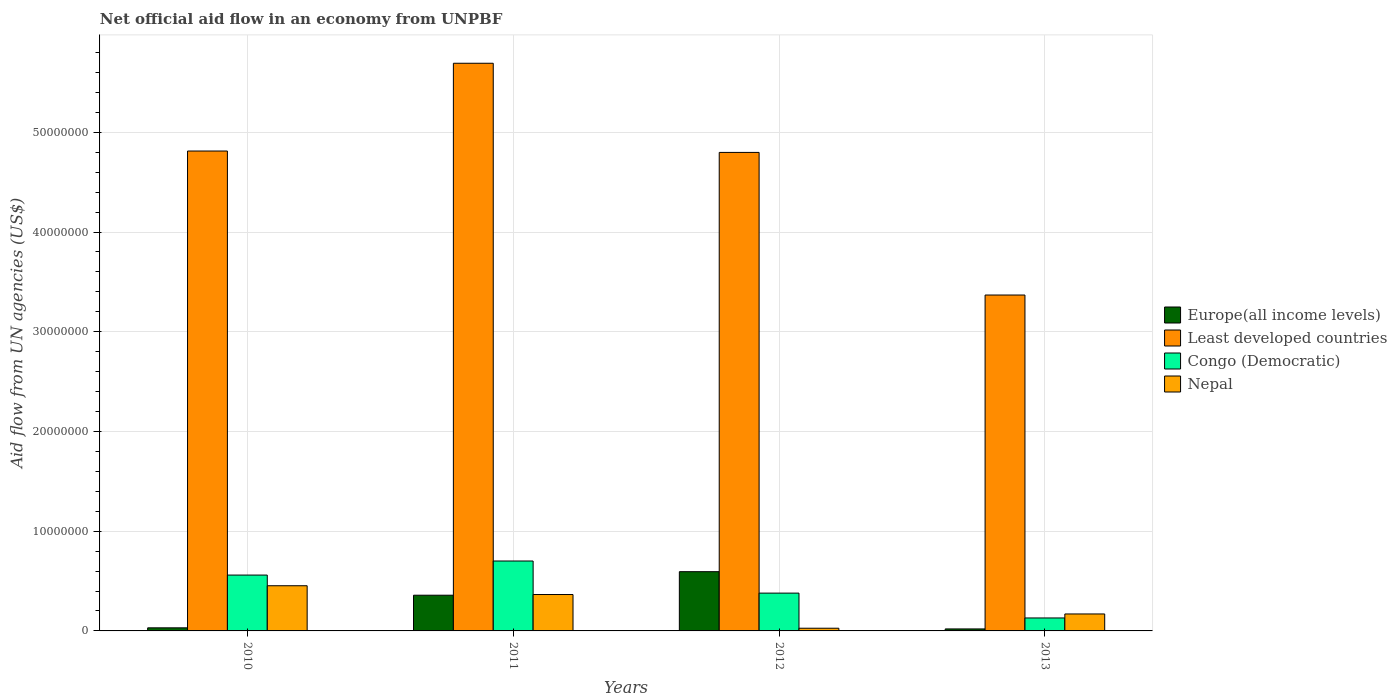Are the number of bars per tick equal to the number of legend labels?
Your answer should be very brief. Yes. Are the number of bars on each tick of the X-axis equal?
Offer a very short reply. Yes. How many bars are there on the 2nd tick from the right?
Provide a short and direct response. 4. What is the label of the 4th group of bars from the left?
Offer a terse response. 2013. In how many cases, is the number of bars for a given year not equal to the number of legend labels?
Your answer should be compact. 0. What is the net official aid flow in Europe(all income levels) in 2010?
Keep it short and to the point. 3.10e+05. Across all years, what is the maximum net official aid flow in Nepal?
Keep it short and to the point. 4.53e+06. Across all years, what is the minimum net official aid flow in Congo (Democratic)?
Provide a succinct answer. 1.30e+06. What is the total net official aid flow in Europe(all income levels) in the graph?
Keep it short and to the point. 1.00e+07. What is the difference between the net official aid flow in Europe(all income levels) in 2012 and that in 2013?
Ensure brevity in your answer.  5.74e+06. What is the difference between the net official aid flow in Europe(all income levels) in 2010 and the net official aid flow in Congo (Democratic) in 2012?
Your answer should be very brief. -3.48e+06. What is the average net official aid flow in Nepal per year?
Give a very brief answer. 2.54e+06. In the year 2013, what is the difference between the net official aid flow in Least developed countries and net official aid flow in Europe(all income levels)?
Give a very brief answer. 3.35e+07. In how many years, is the net official aid flow in Europe(all income levels) greater than 12000000 US$?
Provide a succinct answer. 0. What is the ratio of the net official aid flow in Nepal in 2010 to that in 2011?
Make the answer very short. 1.24. Is the difference between the net official aid flow in Least developed countries in 2011 and 2012 greater than the difference between the net official aid flow in Europe(all income levels) in 2011 and 2012?
Your answer should be very brief. Yes. What is the difference between the highest and the second highest net official aid flow in Europe(all income levels)?
Ensure brevity in your answer.  2.36e+06. What is the difference between the highest and the lowest net official aid flow in Least developed countries?
Provide a succinct answer. 2.32e+07. What does the 1st bar from the left in 2011 represents?
Offer a very short reply. Europe(all income levels). What does the 1st bar from the right in 2012 represents?
Provide a short and direct response. Nepal. Is it the case that in every year, the sum of the net official aid flow in Nepal and net official aid flow in Least developed countries is greater than the net official aid flow in Congo (Democratic)?
Offer a very short reply. Yes. Are the values on the major ticks of Y-axis written in scientific E-notation?
Keep it short and to the point. No. Does the graph contain any zero values?
Your answer should be compact. No. Does the graph contain grids?
Make the answer very short. Yes. What is the title of the graph?
Give a very brief answer. Net official aid flow in an economy from UNPBF. What is the label or title of the X-axis?
Offer a very short reply. Years. What is the label or title of the Y-axis?
Offer a terse response. Aid flow from UN agencies (US$). What is the Aid flow from UN agencies (US$) in Europe(all income levels) in 2010?
Keep it short and to the point. 3.10e+05. What is the Aid flow from UN agencies (US$) in Least developed countries in 2010?
Your answer should be compact. 4.81e+07. What is the Aid flow from UN agencies (US$) in Congo (Democratic) in 2010?
Provide a short and direct response. 5.60e+06. What is the Aid flow from UN agencies (US$) in Nepal in 2010?
Offer a very short reply. 4.53e+06. What is the Aid flow from UN agencies (US$) in Europe(all income levels) in 2011?
Give a very brief answer. 3.58e+06. What is the Aid flow from UN agencies (US$) of Least developed countries in 2011?
Your response must be concise. 5.69e+07. What is the Aid flow from UN agencies (US$) of Congo (Democratic) in 2011?
Give a very brief answer. 7.01e+06. What is the Aid flow from UN agencies (US$) of Nepal in 2011?
Provide a succinct answer. 3.65e+06. What is the Aid flow from UN agencies (US$) of Europe(all income levels) in 2012?
Ensure brevity in your answer.  5.94e+06. What is the Aid flow from UN agencies (US$) of Least developed countries in 2012?
Keep it short and to the point. 4.80e+07. What is the Aid flow from UN agencies (US$) of Congo (Democratic) in 2012?
Ensure brevity in your answer.  3.79e+06. What is the Aid flow from UN agencies (US$) in Nepal in 2012?
Your answer should be very brief. 2.70e+05. What is the Aid flow from UN agencies (US$) in Europe(all income levels) in 2013?
Give a very brief answer. 2.00e+05. What is the Aid flow from UN agencies (US$) in Least developed countries in 2013?
Provide a succinct answer. 3.37e+07. What is the Aid flow from UN agencies (US$) of Congo (Democratic) in 2013?
Your answer should be very brief. 1.30e+06. What is the Aid flow from UN agencies (US$) in Nepal in 2013?
Offer a terse response. 1.70e+06. Across all years, what is the maximum Aid flow from UN agencies (US$) in Europe(all income levels)?
Offer a very short reply. 5.94e+06. Across all years, what is the maximum Aid flow from UN agencies (US$) of Least developed countries?
Offer a terse response. 5.69e+07. Across all years, what is the maximum Aid flow from UN agencies (US$) in Congo (Democratic)?
Give a very brief answer. 7.01e+06. Across all years, what is the maximum Aid flow from UN agencies (US$) of Nepal?
Your answer should be very brief. 4.53e+06. Across all years, what is the minimum Aid flow from UN agencies (US$) of Europe(all income levels)?
Offer a terse response. 2.00e+05. Across all years, what is the minimum Aid flow from UN agencies (US$) in Least developed countries?
Provide a succinct answer. 3.37e+07. Across all years, what is the minimum Aid flow from UN agencies (US$) in Congo (Democratic)?
Make the answer very short. 1.30e+06. Across all years, what is the minimum Aid flow from UN agencies (US$) in Nepal?
Your response must be concise. 2.70e+05. What is the total Aid flow from UN agencies (US$) in Europe(all income levels) in the graph?
Make the answer very short. 1.00e+07. What is the total Aid flow from UN agencies (US$) of Least developed countries in the graph?
Offer a terse response. 1.87e+08. What is the total Aid flow from UN agencies (US$) of Congo (Democratic) in the graph?
Your response must be concise. 1.77e+07. What is the total Aid flow from UN agencies (US$) of Nepal in the graph?
Make the answer very short. 1.02e+07. What is the difference between the Aid flow from UN agencies (US$) in Europe(all income levels) in 2010 and that in 2011?
Your response must be concise. -3.27e+06. What is the difference between the Aid flow from UN agencies (US$) of Least developed countries in 2010 and that in 2011?
Provide a succinct answer. -8.80e+06. What is the difference between the Aid flow from UN agencies (US$) in Congo (Democratic) in 2010 and that in 2011?
Keep it short and to the point. -1.41e+06. What is the difference between the Aid flow from UN agencies (US$) of Nepal in 2010 and that in 2011?
Your response must be concise. 8.80e+05. What is the difference between the Aid flow from UN agencies (US$) in Europe(all income levels) in 2010 and that in 2012?
Keep it short and to the point. -5.63e+06. What is the difference between the Aid flow from UN agencies (US$) in Congo (Democratic) in 2010 and that in 2012?
Offer a very short reply. 1.81e+06. What is the difference between the Aid flow from UN agencies (US$) in Nepal in 2010 and that in 2012?
Your answer should be compact. 4.26e+06. What is the difference between the Aid flow from UN agencies (US$) in Least developed countries in 2010 and that in 2013?
Give a very brief answer. 1.44e+07. What is the difference between the Aid flow from UN agencies (US$) in Congo (Democratic) in 2010 and that in 2013?
Provide a succinct answer. 4.30e+06. What is the difference between the Aid flow from UN agencies (US$) of Nepal in 2010 and that in 2013?
Provide a succinct answer. 2.83e+06. What is the difference between the Aid flow from UN agencies (US$) of Europe(all income levels) in 2011 and that in 2012?
Offer a very short reply. -2.36e+06. What is the difference between the Aid flow from UN agencies (US$) of Least developed countries in 2011 and that in 2012?
Your answer should be very brief. 8.94e+06. What is the difference between the Aid flow from UN agencies (US$) in Congo (Democratic) in 2011 and that in 2012?
Offer a terse response. 3.22e+06. What is the difference between the Aid flow from UN agencies (US$) in Nepal in 2011 and that in 2012?
Give a very brief answer. 3.38e+06. What is the difference between the Aid flow from UN agencies (US$) of Europe(all income levels) in 2011 and that in 2013?
Provide a short and direct response. 3.38e+06. What is the difference between the Aid flow from UN agencies (US$) in Least developed countries in 2011 and that in 2013?
Give a very brief answer. 2.32e+07. What is the difference between the Aid flow from UN agencies (US$) of Congo (Democratic) in 2011 and that in 2013?
Make the answer very short. 5.71e+06. What is the difference between the Aid flow from UN agencies (US$) in Nepal in 2011 and that in 2013?
Your response must be concise. 1.95e+06. What is the difference between the Aid flow from UN agencies (US$) of Europe(all income levels) in 2012 and that in 2013?
Ensure brevity in your answer.  5.74e+06. What is the difference between the Aid flow from UN agencies (US$) in Least developed countries in 2012 and that in 2013?
Your response must be concise. 1.43e+07. What is the difference between the Aid flow from UN agencies (US$) in Congo (Democratic) in 2012 and that in 2013?
Provide a short and direct response. 2.49e+06. What is the difference between the Aid flow from UN agencies (US$) of Nepal in 2012 and that in 2013?
Your answer should be very brief. -1.43e+06. What is the difference between the Aid flow from UN agencies (US$) in Europe(all income levels) in 2010 and the Aid flow from UN agencies (US$) in Least developed countries in 2011?
Ensure brevity in your answer.  -5.66e+07. What is the difference between the Aid flow from UN agencies (US$) in Europe(all income levels) in 2010 and the Aid flow from UN agencies (US$) in Congo (Democratic) in 2011?
Make the answer very short. -6.70e+06. What is the difference between the Aid flow from UN agencies (US$) of Europe(all income levels) in 2010 and the Aid flow from UN agencies (US$) of Nepal in 2011?
Offer a very short reply. -3.34e+06. What is the difference between the Aid flow from UN agencies (US$) in Least developed countries in 2010 and the Aid flow from UN agencies (US$) in Congo (Democratic) in 2011?
Make the answer very short. 4.11e+07. What is the difference between the Aid flow from UN agencies (US$) of Least developed countries in 2010 and the Aid flow from UN agencies (US$) of Nepal in 2011?
Your answer should be very brief. 4.45e+07. What is the difference between the Aid flow from UN agencies (US$) of Congo (Democratic) in 2010 and the Aid flow from UN agencies (US$) of Nepal in 2011?
Give a very brief answer. 1.95e+06. What is the difference between the Aid flow from UN agencies (US$) in Europe(all income levels) in 2010 and the Aid flow from UN agencies (US$) in Least developed countries in 2012?
Give a very brief answer. -4.77e+07. What is the difference between the Aid flow from UN agencies (US$) in Europe(all income levels) in 2010 and the Aid flow from UN agencies (US$) in Congo (Democratic) in 2012?
Your answer should be very brief. -3.48e+06. What is the difference between the Aid flow from UN agencies (US$) in Least developed countries in 2010 and the Aid flow from UN agencies (US$) in Congo (Democratic) in 2012?
Provide a short and direct response. 4.43e+07. What is the difference between the Aid flow from UN agencies (US$) of Least developed countries in 2010 and the Aid flow from UN agencies (US$) of Nepal in 2012?
Keep it short and to the point. 4.78e+07. What is the difference between the Aid flow from UN agencies (US$) of Congo (Democratic) in 2010 and the Aid flow from UN agencies (US$) of Nepal in 2012?
Make the answer very short. 5.33e+06. What is the difference between the Aid flow from UN agencies (US$) of Europe(all income levels) in 2010 and the Aid flow from UN agencies (US$) of Least developed countries in 2013?
Offer a terse response. -3.34e+07. What is the difference between the Aid flow from UN agencies (US$) of Europe(all income levels) in 2010 and the Aid flow from UN agencies (US$) of Congo (Democratic) in 2013?
Make the answer very short. -9.90e+05. What is the difference between the Aid flow from UN agencies (US$) in Europe(all income levels) in 2010 and the Aid flow from UN agencies (US$) in Nepal in 2013?
Your answer should be compact. -1.39e+06. What is the difference between the Aid flow from UN agencies (US$) of Least developed countries in 2010 and the Aid flow from UN agencies (US$) of Congo (Democratic) in 2013?
Give a very brief answer. 4.68e+07. What is the difference between the Aid flow from UN agencies (US$) in Least developed countries in 2010 and the Aid flow from UN agencies (US$) in Nepal in 2013?
Your answer should be compact. 4.64e+07. What is the difference between the Aid flow from UN agencies (US$) of Congo (Democratic) in 2010 and the Aid flow from UN agencies (US$) of Nepal in 2013?
Give a very brief answer. 3.90e+06. What is the difference between the Aid flow from UN agencies (US$) of Europe(all income levels) in 2011 and the Aid flow from UN agencies (US$) of Least developed countries in 2012?
Provide a short and direct response. -4.44e+07. What is the difference between the Aid flow from UN agencies (US$) in Europe(all income levels) in 2011 and the Aid flow from UN agencies (US$) in Congo (Democratic) in 2012?
Keep it short and to the point. -2.10e+05. What is the difference between the Aid flow from UN agencies (US$) in Europe(all income levels) in 2011 and the Aid flow from UN agencies (US$) in Nepal in 2012?
Give a very brief answer. 3.31e+06. What is the difference between the Aid flow from UN agencies (US$) in Least developed countries in 2011 and the Aid flow from UN agencies (US$) in Congo (Democratic) in 2012?
Offer a terse response. 5.31e+07. What is the difference between the Aid flow from UN agencies (US$) of Least developed countries in 2011 and the Aid flow from UN agencies (US$) of Nepal in 2012?
Give a very brief answer. 5.66e+07. What is the difference between the Aid flow from UN agencies (US$) in Congo (Democratic) in 2011 and the Aid flow from UN agencies (US$) in Nepal in 2012?
Give a very brief answer. 6.74e+06. What is the difference between the Aid flow from UN agencies (US$) of Europe(all income levels) in 2011 and the Aid flow from UN agencies (US$) of Least developed countries in 2013?
Provide a short and direct response. -3.01e+07. What is the difference between the Aid flow from UN agencies (US$) of Europe(all income levels) in 2011 and the Aid flow from UN agencies (US$) of Congo (Democratic) in 2013?
Offer a terse response. 2.28e+06. What is the difference between the Aid flow from UN agencies (US$) in Europe(all income levels) in 2011 and the Aid flow from UN agencies (US$) in Nepal in 2013?
Offer a very short reply. 1.88e+06. What is the difference between the Aid flow from UN agencies (US$) of Least developed countries in 2011 and the Aid flow from UN agencies (US$) of Congo (Democratic) in 2013?
Offer a terse response. 5.56e+07. What is the difference between the Aid flow from UN agencies (US$) in Least developed countries in 2011 and the Aid flow from UN agencies (US$) in Nepal in 2013?
Offer a terse response. 5.52e+07. What is the difference between the Aid flow from UN agencies (US$) of Congo (Democratic) in 2011 and the Aid flow from UN agencies (US$) of Nepal in 2013?
Make the answer very short. 5.31e+06. What is the difference between the Aid flow from UN agencies (US$) of Europe(all income levels) in 2012 and the Aid flow from UN agencies (US$) of Least developed countries in 2013?
Your answer should be very brief. -2.77e+07. What is the difference between the Aid flow from UN agencies (US$) of Europe(all income levels) in 2012 and the Aid flow from UN agencies (US$) of Congo (Democratic) in 2013?
Make the answer very short. 4.64e+06. What is the difference between the Aid flow from UN agencies (US$) of Europe(all income levels) in 2012 and the Aid flow from UN agencies (US$) of Nepal in 2013?
Provide a short and direct response. 4.24e+06. What is the difference between the Aid flow from UN agencies (US$) of Least developed countries in 2012 and the Aid flow from UN agencies (US$) of Congo (Democratic) in 2013?
Your response must be concise. 4.67e+07. What is the difference between the Aid flow from UN agencies (US$) in Least developed countries in 2012 and the Aid flow from UN agencies (US$) in Nepal in 2013?
Provide a succinct answer. 4.63e+07. What is the difference between the Aid flow from UN agencies (US$) of Congo (Democratic) in 2012 and the Aid flow from UN agencies (US$) of Nepal in 2013?
Keep it short and to the point. 2.09e+06. What is the average Aid flow from UN agencies (US$) in Europe(all income levels) per year?
Provide a succinct answer. 2.51e+06. What is the average Aid flow from UN agencies (US$) of Least developed countries per year?
Provide a succinct answer. 4.67e+07. What is the average Aid flow from UN agencies (US$) in Congo (Democratic) per year?
Your answer should be compact. 4.42e+06. What is the average Aid flow from UN agencies (US$) of Nepal per year?
Make the answer very short. 2.54e+06. In the year 2010, what is the difference between the Aid flow from UN agencies (US$) of Europe(all income levels) and Aid flow from UN agencies (US$) of Least developed countries?
Your answer should be very brief. -4.78e+07. In the year 2010, what is the difference between the Aid flow from UN agencies (US$) in Europe(all income levels) and Aid flow from UN agencies (US$) in Congo (Democratic)?
Your answer should be very brief. -5.29e+06. In the year 2010, what is the difference between the Aid flow from UN agencies (US$) in Europe(all income levels) and Aid flow from UN agencies (US$) in Nepal?
Offer a very short reply. -4.22e+06. In the year 2010, what is the difference between the Aid flow from UN agencies (US$) in Least developed countries and Aid flow from UN agencies (US$) in Congo (Democratic)?
Your answer should be very brief. 4.25e+07. In the year 2010, what is the difference between the Aid flow from UN agencies (US$) of Least developed countries and Aid flow from UN agencies (US$) of Nepal?
Keep it short and to the point. 4.36e+07. In the year 2010, what is the difference between the Aid flow from UN agencies (US$) in Congo (Democratic) and Aid flow from UN agencies (US$) in Nepal?
Your answer should be very brief. 1.07e+06. In the year 2011, what is the difference between the Aid flow from UN agencies (US$) in Europe(all income levels) and Aid flow from UN agencies (US$) in Least developed countries?
Keep it short and to the point. -5.33e+07. In the year 2011, what is the difference between the Aid flow from UN agencies (US$) in Europe(all income levels) and Aid flow from UN agencies (US$) in Congo (Democratic)?
Your answer should be compact. -3.43e+06. In the year 2011, what is the difference between the Aid flow from UN agencies (US$) in Europe(all income levels) and Aid flow from UN agencies (US$) in Nepal?
Offer a very short reply. -7.00e+04. In the year 2011, what is the difference between the Aid flow from UN agencies (US$) in Least developed countries and Aid flow from UN agencies (US$) in Congo (Democratic)?
Provide a succinct answer. 4.99e+07. In the year 2011, what is the difference between the Aid flow from UN agencies (US$) in Least developed countries and Aid flow from UN agencies (US$) in Nepal?
Ensure brevity in your answer.  5.33e+07. In the year 2011, what is the difference between the Aid flow from UN agencies (US$) of Congo (Democratic) and Aid flow from UN agencies (US$) of Nepal?
Ensure brevity in your answer.  3.36e+06. In the year 2012, what is the difference between the Aid flow from UN agencies (US$) of Europe(all income levels) and Aid flow from UN agencies (US$) of Least developed countries?
Your answer should be very brief. -4.20e+07. In the year 2012, what is the difference between the Aid flow from UN agencies (US$) of Europe(all income levels) and Aid flow from UN agencies (US$) of Congo (Democratic)?
Provide a short and direct response. 2.15e+06. In the year 2012, what is the difference between the Aid flow from UN agencies (US$) of Europe(all income levels) and Aid flow from UN agencies (US$) of Nepal?
Provide a succinct answer. 5.67e+06. In the year 2012, what is the difference between the Aid flow from UN agencies (US$) of Least developed countries and Aid flow from UN agencies (US$) of Congo (Democratic)?
Provide a succinct answer. 4.42e+07. In the year 2012, what is the difference between the Aid flow from UN agencies (US$) of Least developed countries and Aid flow from UN agencies (US$) of Nepal?
Offer a terse response. 4.77e+07. In the year 2012, what is the difference between the Aid flow from UN agencies (US$) in Congo (Democratic) and Aid flow from UN agencies (US$) in Nepal?
Make the answer very short. 3.52e+06. In the year 2013, what is the difference between the Aid flow from UN agencies (US$) in Europe(all income levels) and Aid flow from UN agencies (US$) in Least developed countries?
Give a very brief answer. -3.35e+07. In the year 2013, what is the difference between the Aid flow from UN agencies (US$) in Europe(all income levels) and Aid flow from UN agencies (US$) in Congo (Democratic)?
Ensure brevity in your answer.  -1.10e+06. In the year 2013, what is the difference between the Aid flow from UN agencies (US$) of Europe(all income levels) and Aid flow from UN agencies (US$) of Nepal?
Offer a terse response. -1.50e+06. In the year 2013, what is the difference between the Aid flow from UN agencies (US$) in Least developed countries and Aid flow from UN agencies (US$) in Congo (Democratic)?
Ensure brevity in your answer.  3.24e+07. In the year 2013, what is the difference between the Aid flow from UN agencies (US$) of Least developed countries and Aid flow from UN agencies (US$) of Nepal?
Provide a short and direct response. 3.20e+07. In the year 2013, what is the difference between the Aid flow from UN agencies (US$) of Congo (Democratic) and Aid flow from UN agencies (US$) of Nepal?
Your answer should be very brief. -4.00e+05. What is the ratio of the Aid flow from UN agencies (US$) of Europe(all income levels) in 2010 to that in 2011?
Keep it short and to the point. 0.09. What is the ratio of the Aid flow from UN agencies (US$) of Least developed countries in 2010 to that in 2011?
Provide a short and direct response. 0.85. What is the ratio of the Aid flow from UN agencies (US$) of Congo (Democratic) in 2010 to that in 2011?
Offer a very short reply. 0.8. What is the ratio of the Aid flow from UN agencies (US$) of Nepal in 2010 to that in 2011?
Ensure brevity in your answer.  1.24. What is the ratio of the Aid flow from UN agencies (US$) of Europe(all income levels) in 2010 to that in 2012?
Offer a terse response. 0.05. What is the ratio of the Aid flow from UN agencies (US$) of Congo (Democratic) in 2010 to that in 2012?
Ensure brevity in your answer.  1.48. What is the ratio of the Aid flow from UN agencies (US$) of Nepal in 2010 to that in 2012?
Give a very brief answer. 16.78. What is the ratio of the Aid flow from UN agencies (US$) in Europe(all income levels) in 2010 to that in 2013?
Your answer should be compact. 1.55. What is the ratio of the Aid flow from UN agencies (US$) in Least developed countries in 2010 to that in 2013?
Ensure brevity in your answer.  1.43. What is the ratio of the Aid flow from UN agencies (US$) in Congo (Democratic) in 2010 to that in 2013?
Give a very brief answer. 4.31. What is the ratio of the Aid flow from UN agencies (US$) of Nepal in 2010 to that in 2013?
Provide a short and direct response. 2.66. What is the ratio of the Aid flow from UN agencies (US$) in Europe(all income levels) in 2011 to that in 2012?
Provide a short and direct response. 0.6. What is the ratio of the Aid flow from UN agencies (US$) of Least developed countries in 2011 to that in 2012?
Keep it short and to the point. 1.19. What is the ratio of the Aid flow from UN agencies (US$) of Congo (Democratic) in 2011 to that in 2012?
Offer a very short reply. 1.85. What is the ratio of the Aid flow from UN agencies (US$) of Nepal in 2011 to that in 2012?
Provide a succinct answer. 13.52. What is the ratio of the Aid flow from UN agencies (US$) in Least developed countries in 2011 to that in 2013?
Your answer should be compact. 1.69. What is the ratio of the Aid flow from UN agencies (US$) of Congo (Democratic) in 2011 to that in 2013?
Make the answer very short. 5.39. What is the ratio of the Aid flow from UN agencies (US$) in Nepal in 2011 to that in 2013?
Provide a short and direct response. 2.15. What is the ratio of the Aid flow from UN agencies (US$) in Europe(all income levels) in 2012 to that in 2013?
Provide a short and direct response. 29.7. What is the ratio of the Aid flow from UN agencies (US$) in Least developed countries in 2012 to that in 2013?
Provide a short and direct response. 1.42. What is the ratio of the Aid flow from UN agencies (US$) in Congo (Democratic) in 2012 to that in 2013?
Offer a very short reply. 2.92. What is the ratio of the Aid flow from UN agencies (US$) in Nepal in 2012 to that in 2013?
Your answer should be compact. 0.16. What is the difference between the highest and the second highest Aid flow from UN agencies (US$) in Europe(all income levels)?
Offer a terse response. 2.36e+06. What is the difference between the highest and the second highest Aid flow from UN agencies (US$) in Least developed countries?
Your response must be concise. 8.80e+06. What is the difference between the highest and the second highest Aid flow from UN agencies (US$) of Congo (Democratic)?
Your answer should be very brief. 1.41e+06. What is the difference between the highest and the second highest Aid flow from UN agencies (US$) of Nepal?
Provide a short and direct response. 8.80e+05. What is the difference between the highest and the lowest Aid flow from UN agencies (US$) in Europe(all income levels)?
Your answer should be compact. 5.74e+06. What is the difference between the highest and the lowest Aid flow from UN agencies (US$) of Least developed countries?
Ensure brevity in your answer.  2.32e+07. What is the difference between the highest and the lowest Aid flow from UN agencies (US$) of Congo (Democratic)?
Keep it short and to the point. 5.71e+06. What is the difference between the highest and the lowest Aid flow from UN agencies (US$) of Nepal?
Keep it short and to the point. 4.26e+06. 